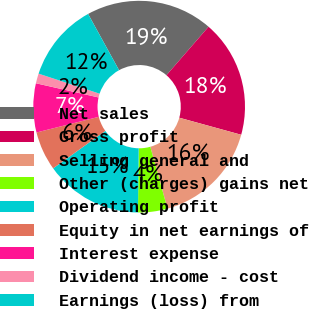Convert chart. <chart><loc_0><loc_0><loc_500><loc_500><pie_chart><fcel>Net sales<fcel>Gross profit<fcel>Selling general and<fcel>Other (charges) gains net<fcel>Operating profit<fcel>Equity in net earnings of<fcel>Interest expense<fcel>Dividend income - cost<fcel>Earnings (loss) from<nl><fcel>19.39%<fcel>17.9%<fcel>16.41%<fcel>4.49%<fcel>14.92%<fcel>5.98%<fcel>7.47%<fcel>1.5%<fcel>11.94%<nl></chart> 